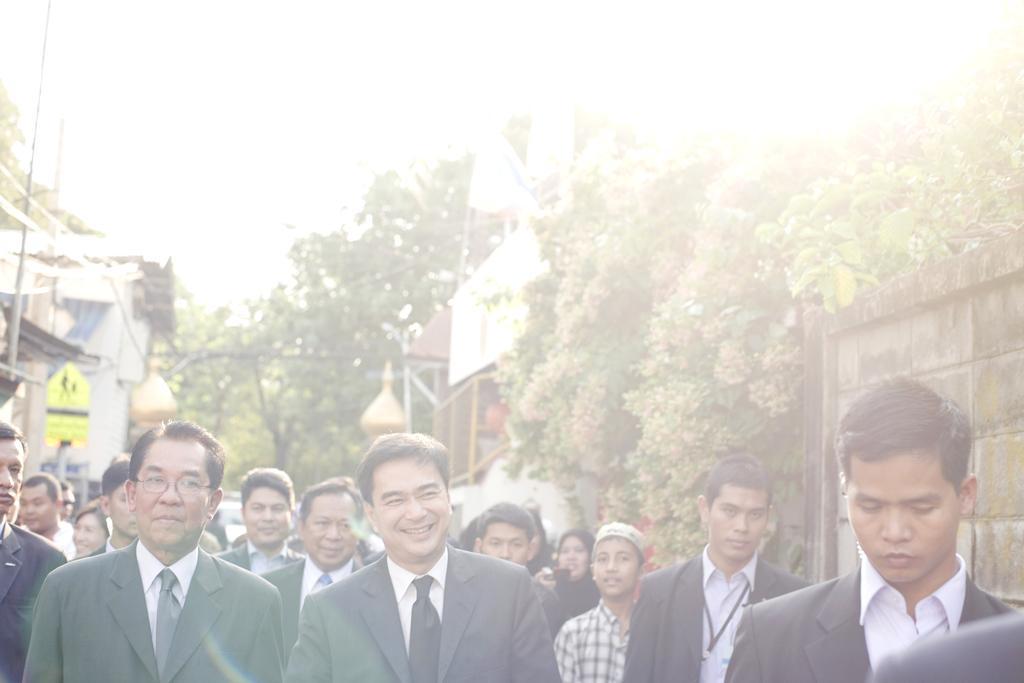What are the people in the image doing? The persons standing on the ground in the image are likely standing or waiting. What can be seen in the sky in the image? The sky is visible in the image, but no specific details about the sky are mentioned. What type of vegetation is present in the image? There are trees in the image. What type of structures can be seen in the image? There are buildings in the image. What are the poles used for in the image? The purpose of the poles in the image is not specified, but they could be for support, signage, or other purposes. What additional decorative elements are visible in the image? Decors are visible in the image, but their specific nature is not mentioned. What type of leather is being used to make the mom's attempt in the image? There is no mention of a mom or an attempt in the image, nor is there any reference to leather. 